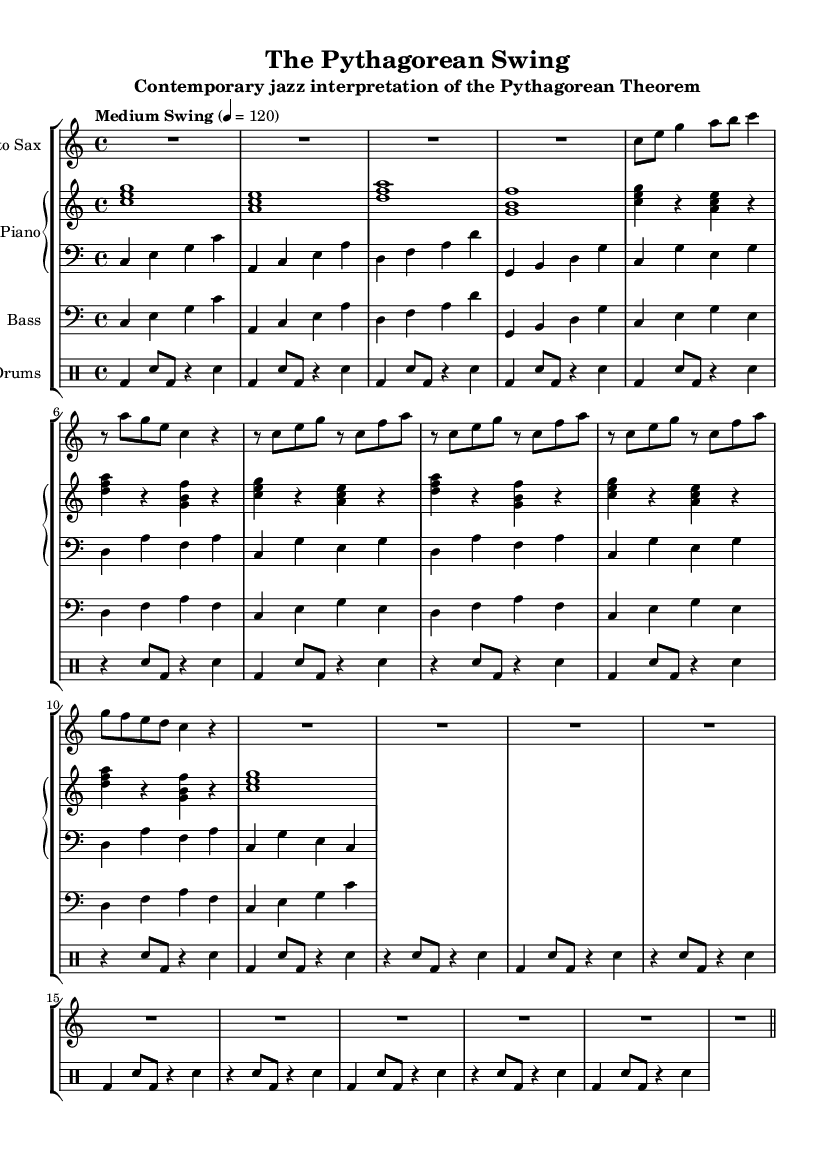What is the key signature of this music? The key signature is C major, which has no sharps or flats indicated in the sheet music. It can be identified by looking at the section labeled with the key signature, just before the time signature.
Answer: C major What is the time signature of this music? The time signature indicated in the sheet music is 4/4, which signifies four beats per measure. This can be found near the beginning of the score, following the key signature.
Answer: 4/4 What tempo is indicated for this piece? The indicated tempo for this piece is "Medium Swing" set at 120 beats per minute, which informs the performers how fast the music should be played. This is explicitly marked above the staff with the tempo marking.
Answer: Medium Swing 120 How many measures are in the section where the saxophone plays the main motif? The saxophone plays the main motif across 10 measures, including repetitions and rests that are counted within the given measures of music. By analyzing the saxophone part, we can count the full range of measures visually or through notation.
Answer: 10 What is the primary rhythmic pattern used in the drum part? The primary rhythmic pattern in the drum part consists of a bass drum followed by a snare drum played in alternation with rests. This can be determined by analyzing the drum notation and observing the repeating structure and placement of the notes.
Answer: Bass-Snare What does the use of chords in the piano part suggest about the harmonic structure? The use of triads (three-note chords) in the piano part indicates the harmonic structure is built with simple and complete chords, serving as the harmonic foundation for the piece. Each chord consists of the root, third, and fifth, forming a standard jazz harmonic backdrop.
Answer: Triads How does the bass part relate to the overall structure of the piece? The bass part provides a consistent harmonic foundation that mirrors the piano chords but transposed down an octave. This relationship supports the harmonic progression and adds depth to the jazz interpretation of the theme. By examining the bass line in conjunction with the piano chords, one can see this structural interdependence clearly.
Answer: Supports harmonic foundation 